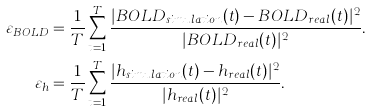<formula> <loc_0><loc_0><loc_500><loc_500>\varepsilon _ { B O L D } & = \frac { 1 } { T } \sum _ { t = 1 } ^ { T } \frac { | B O L D _ { s i m u l a t i o n } ( t ) - B O L D _ { r e a l } ( t ) | ^ { 2 } } { | B O L D _ { r e a l } ( t ) | ^ { 2 } } . \\ \varepsilon _ { h } & = \frac { 1 } { T } \sum _ { t = 1 } ^ { T } \frac { | h _ { s i m u l a t i o n } ( t ) - h _ { r e a l } ( t ) | ^ { 2 } } { | h _ { r e a l } ( t ) | ^ { 2 } } .</formula> 